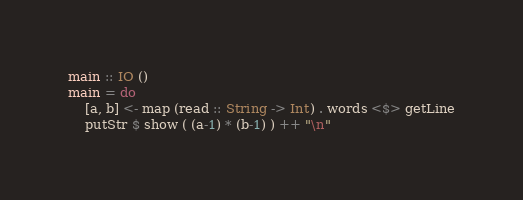Convert code to text. <code><loc_0><loc_0><loc_500><loc_500><_Haskell_>main :: IO ()
main = do
    [a, b] <- map (read :: String -> Int) . words <$> getLine
    putStr $ show ( (a-1) * (b-1) ) ++ "\n"
</code> 